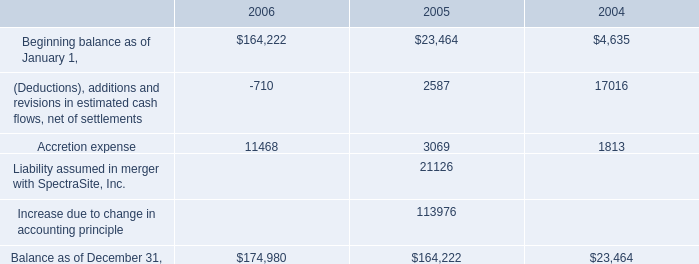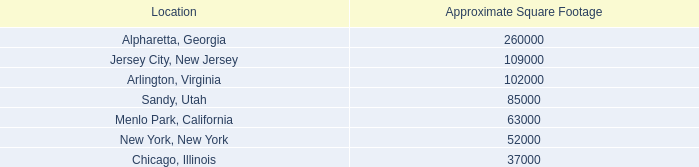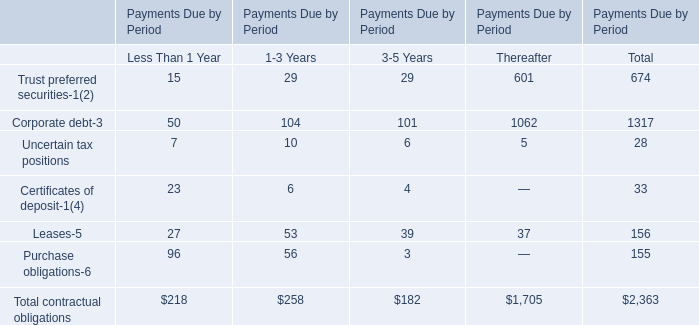What is the sum of Sandy, Utah of Approximate Square Footage, Balance as of December 31, of 2004, and Total contractual obligations of Payments Due by Period Thereafter ? 
Computations: ((85000.0 + 23464.0) + 1705.0)
Answer: 110169.0. 